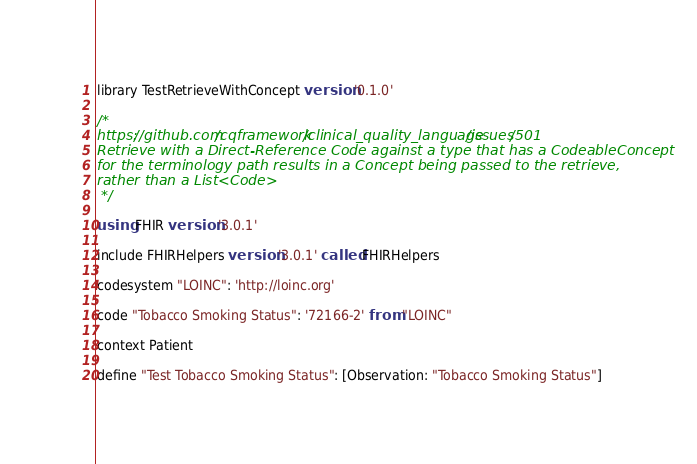<code> <loc_0><loc_0><loc_500><loc_500><_SQL_>library TestRetrieveWithConcept version '0.1.0'

/*
https://github.com/cqframework/clinical_quality_language/issues/501
Retrieve with a Direct-Reference Code against a type that has a CodeableConcept
for the terminology path results in a Concept being passed to the retrieve,
rather than a List<Code>
 */

using FHIR version '3.0.1'

include FHIRHelpers version '3.0.1' called FHIRHelpers

codesystem "LOINC": 'http://loinc.org'

code "Tobacco Smoking Status": '72166-2' from "LOINC"

context Patient

define "Test Tobacco Smoking Status": [Observation: "Tobacco Smoking Status"]</code> 